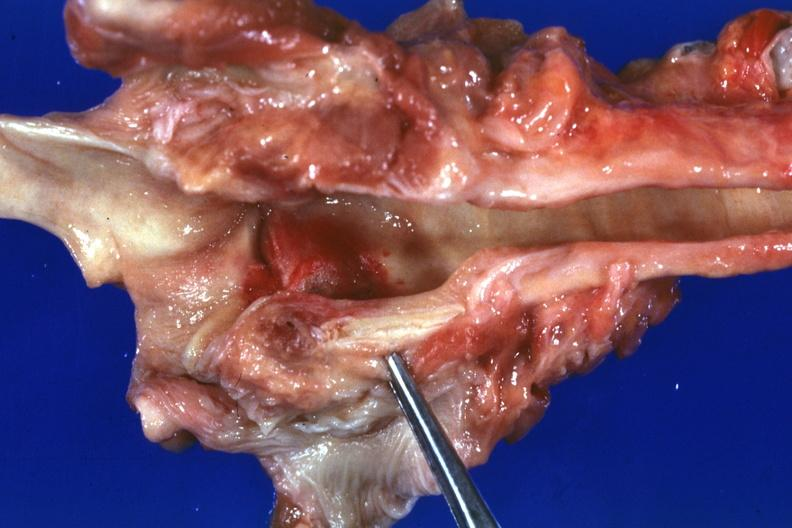how does this image show large hemorrhagic lesion about left cord due to tube and candida possibly the portal of entry case of myeloproliferative syndrome?
Answer the question using a single word or phrase. With pancytopenia 